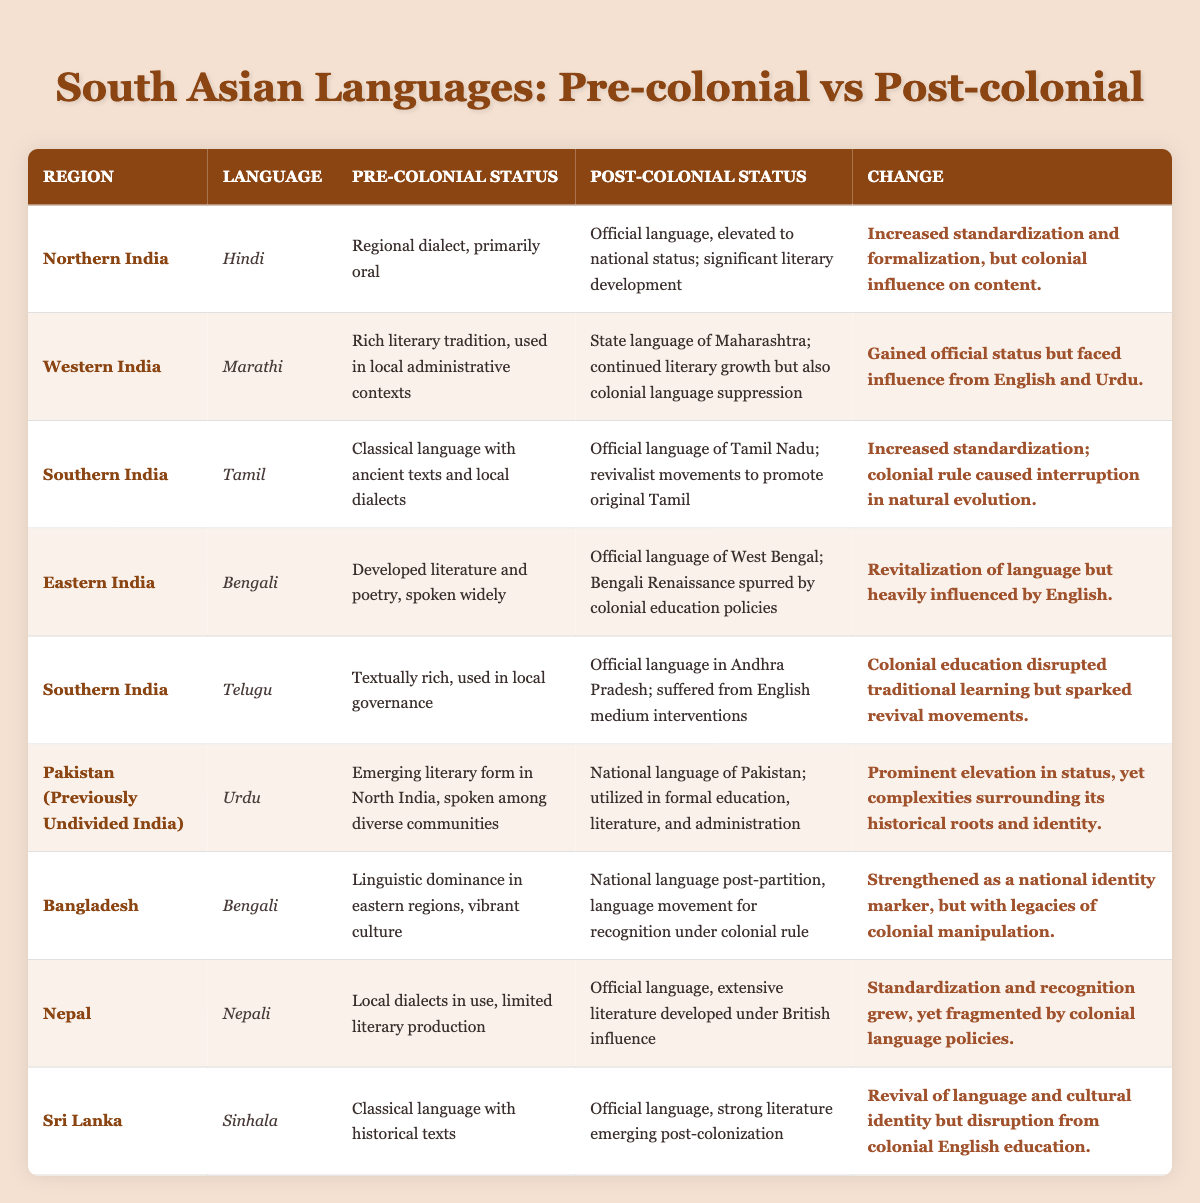What was the status of Hindi in Northern India before colonial times? The table shows that Hindi was described as a regional dialect, primarily oral, before colonial times.
Answer: Regional dialect, primarily oral Did Tamil have any literary development in Southern India during the pre-colonial period? According to the table, Tamil was a classical language with ancient texts and local dialects, indicating a rich literary development even before colonial influence.
Answer: Yes Which language was primarily spoken in Bangladesh before colonization? The table states that Bengali had linguistic dominance in the eastern regions, suggesting it was widely spoken before colonization.
Answer: Bengali What changes happened to Urdu's status in Pakistan after colonization? The table indicates that Urdu was elevated to the national language of Pakistan and became used in formal education, literature, and administration after colonization.
Answer: Elevated to national language and used in formal education Is it true that colonial rule caused an interruption in the natural evolution of Tamil? The table confirms that the change for Tamil included increased standardization and that colonial rule did indeed disrupt its natural evolution.
Answer: Yes How many languages in the table became official languages post-colonial? The languages listed as official post-colonial include Hindi, Marathi, Tamil, Bengali, Telugu, Urdu, Nepali, and Sinhala, totaling 8 languages.
Answer: 8 What was a common consequence for languages in India after colonization? The table shows that many languages faced colonial language suppression and English influence while gaining official status post-colonization, highlighting a common theme of colonial intervention.
Answer: Colonial language suppression and English influence Which language experienced a revitalization post-colonial with a strong connection to cultural identity? The table shows that Bengali in Bangladesh strengthened as a national identity marker post-partition, indicating a revitalization connected to cultural identity.
Answer: Bengali Was the status of Nepali improved due to colonial influence? The table indicates that Nepali became the official language with extensive literature developed under British influence, suggesting its status was indeed improved.
Answer: Yes 